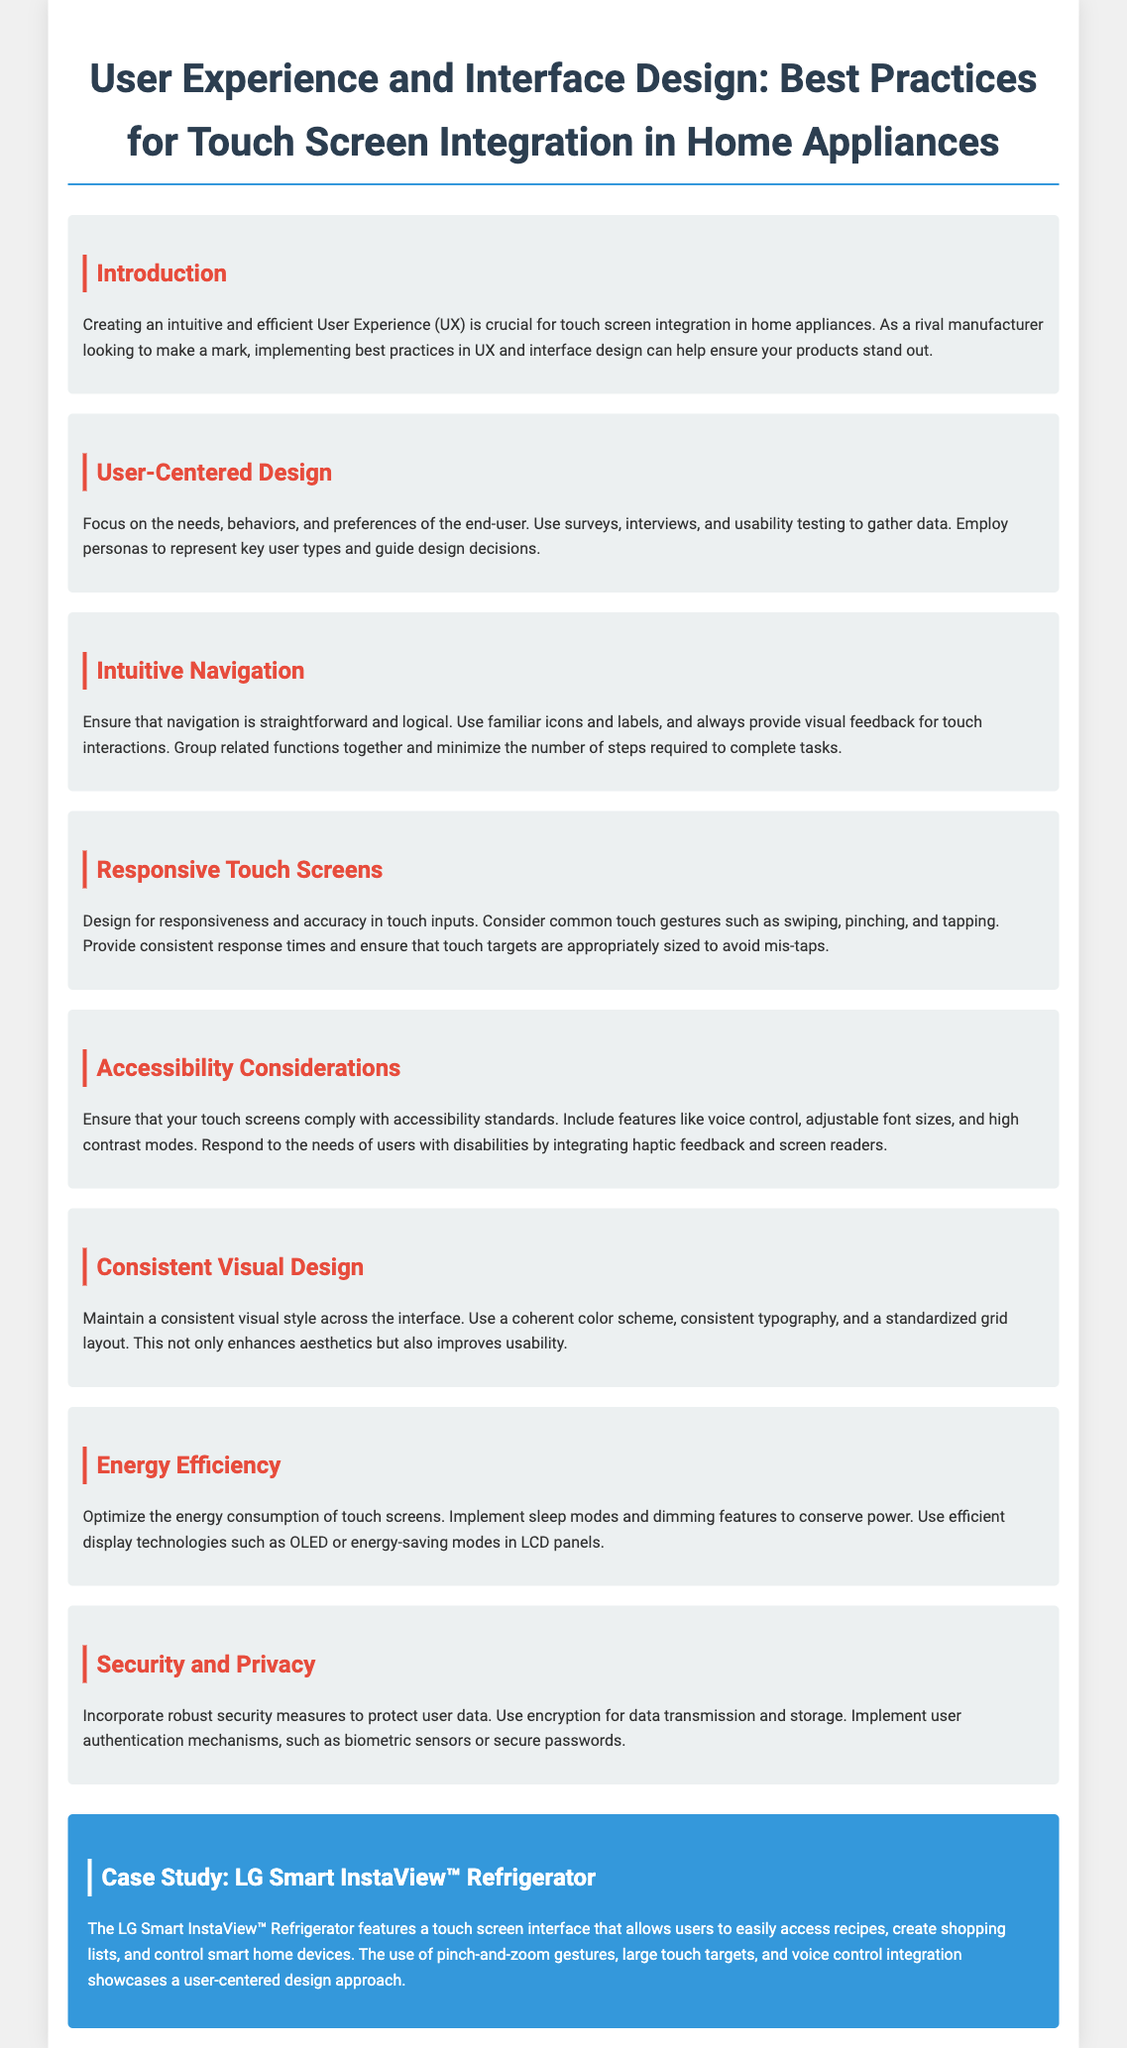What is the main focus of the document? The main focus of the document is to provide best practices for touch screen integration in home appliances, specifically regarding User Experience and Interface Design.
Answer: Best practices for touch screen integration What is one method suggested for gathering user data? One method suggested for gathering user data is to use surveys.
Answer: Surveys What feature is highlighted for ensuring accessibility? The feature highlighted for ensuring accessibility is voice control.
Answer: Voice control What does "responsive touch screens" refer to? "Responsive touch screens" refers to designing for responsiveness and accuracy in touch inputs.
Answer: Responsiveness and accuracy Which appliance is featured in the case study? The appliance featured in the case study is the LG Smart InstaView™ Refrigerator.
Answer: LG Smart InstaView™ Refrigerator What design aspect enhances aesthetics and usability? A consistent visual style enhances aesthetics and usability.
Answer: Consistent visual style What technology is suggested to optimize energy consumption? OLED is suggested to optimize energy consumption.
Answer: OLED What type of user feedback is important for touch interactions? Visual feedback is important for touch interactions.
Answer: Visual feedback 